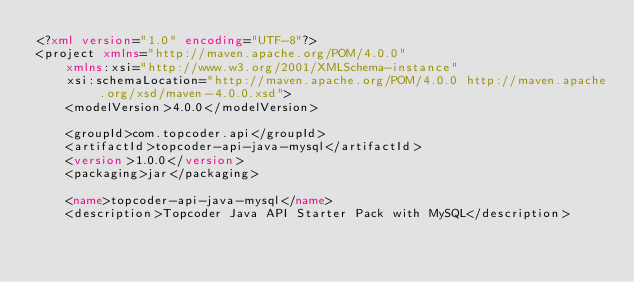Convert code to text. <code><loc_0><loc_0><loc_500><loc_500><_XML_><?xml version="1.0" encoding="UTF-8"?>
<project xmlns="http://maven.apache.org/POM/4.0.0"
	xmlns:xsi="http://www.w3.org/2001/XMLSchema-instance"
	xsi:schemaLocation="http://maven.apache.org/POM/4.0.0 http://maven.apache.org/xsd/maven-4.0.0.xsd">
	<modelVersion>4.0.0</modelVersion>

	<groupId>com.topcoder.api</groupId>
	<artifactId>topcoder-api-java-mysql</artifactId>
	<version>1.0.0</version>
	<packaging>jar</packaging>

	<name>topcoder-api-java-mysql</name>
	<description>Topcoder Java API Starter Pack with MySQL</description>
</code> 